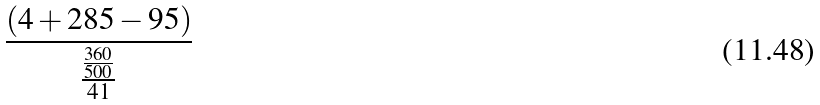Convert formula to latex. <formula><loc_0><loc_0><loc_500><loc_500>\frac { ( 4 + 2 8 5 - 9 5 ) } { \frac { \frac { 3 6 0 } { 5 0 0 } } { 4 1 } }</formula> 